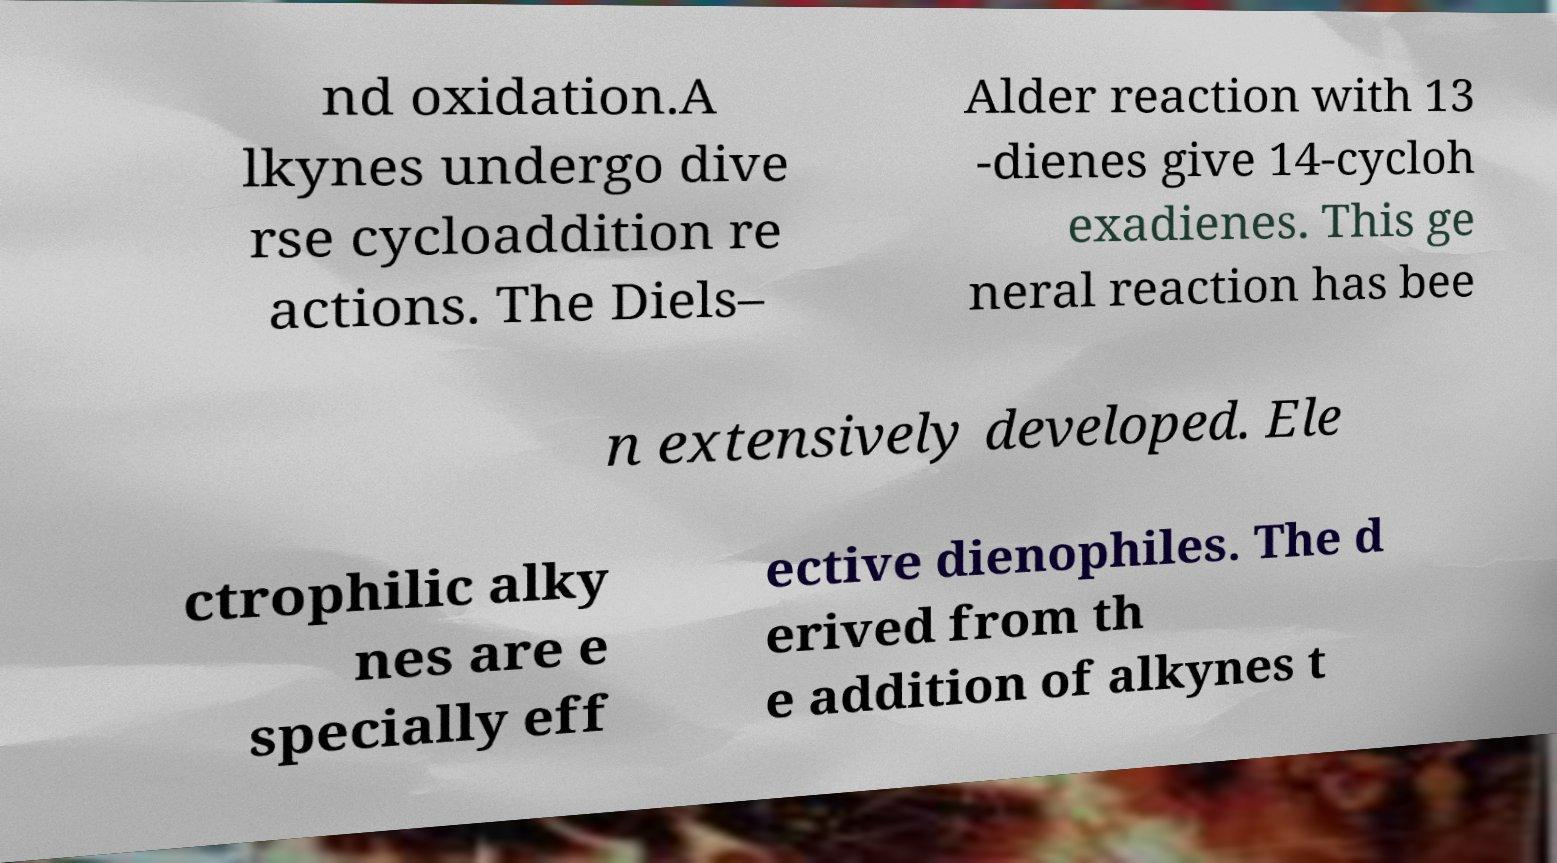Could you extract and type out the text from this image? nd oxidation.A lkynes undergo dive rse cycloaddition re actions. The Diels– Alder reaction with 13 -dienes give 14-cycloh exadienes. This ge neral reaction has bee n extensively developed. Ele ctrophilic alky nes are e specially eff ective dienophiles. The d erived from th e addition of alkynes t 